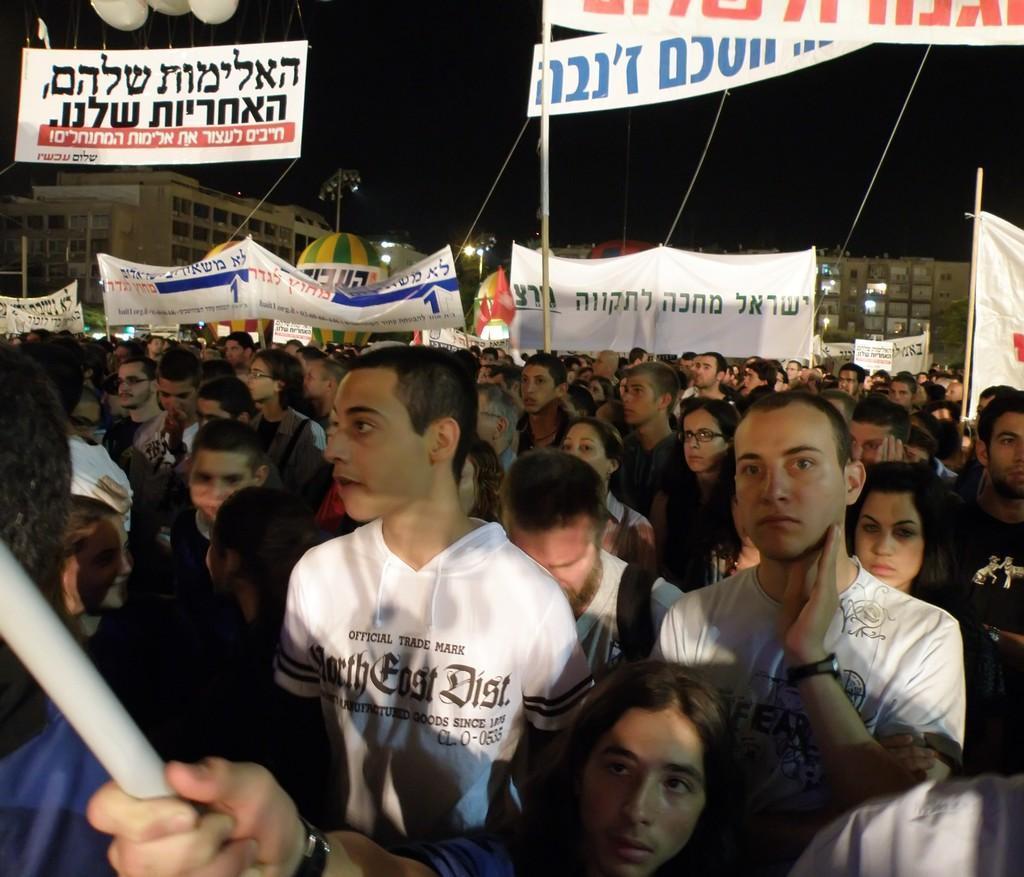Could you give a brief overview of what you see in this image? In the foreground of the picture we can see people. In middle of the picture there are banners and people. In the background there are buildings. At the top there is sky. 